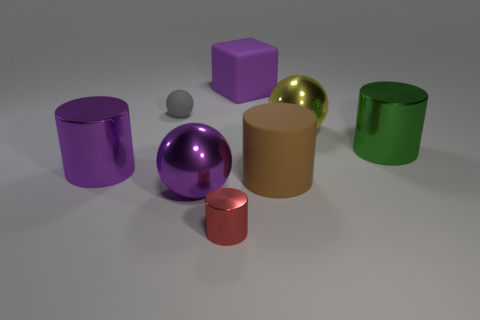There is a red thing that is the same shape as the large green shiny object; what is its material?
Your response must be concise. Metal. The object behind the small sphere is what color?
Offer a very short reply. Purple. How big is the red shiny cylinder?
Make the answer very short. Small. Is the size of the gray sphere the same as the shiny cylinder that is on the right side of the brown cylinder?
Provide a succinct answer. No. There is a object in front of the big shiny thing in front of the shiny cylinder to the left of the red shiny cylinder; what color is it?
Your response must be concise. Red. Is the material of the large sphere in front of the yellow shiny thing the same as the purple cube?
Keep it short and to the point. No. What number of other objects are there of the same material as the gray sphere?
Give a very brief answer. 2. What is the material of the brown cylinder that is the same size as the purple cube?
Your response must be concise. Rubber. There is a big rubber thing that is behind the large yellow thing; does it have the same shape as the small object that is in front of the green cylinder?
Keep it short and to the point. No. What shape is the brown matte thing that is the same size as the green cylinder?
Give a very brief answer. Cylinder. 